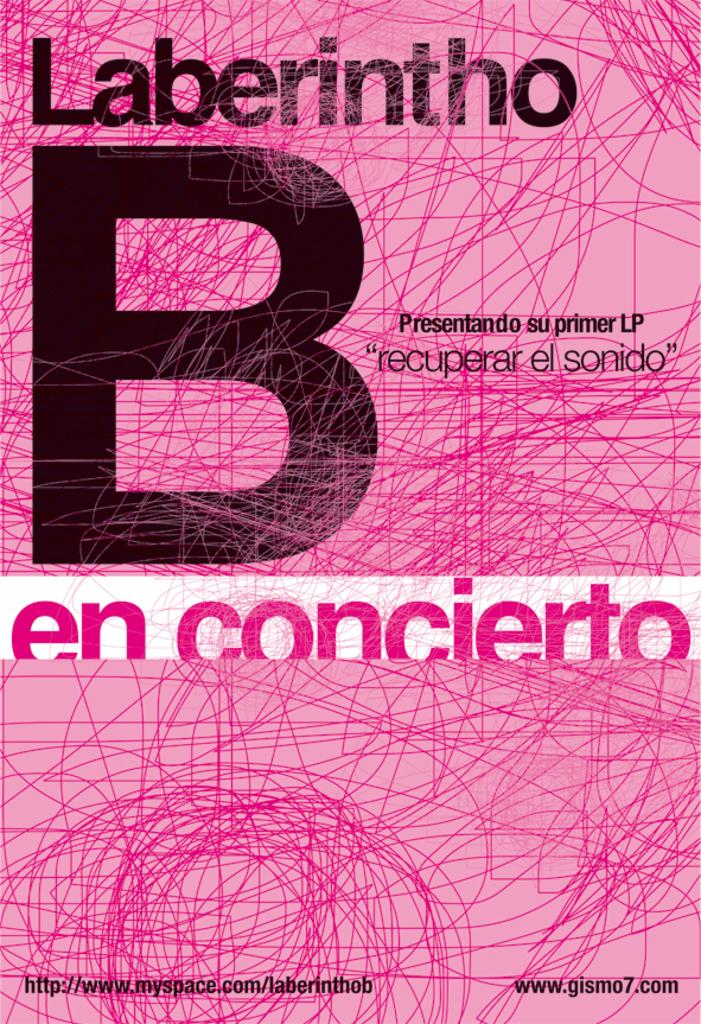<image>
Create a compact narrative representing the image presented. A book cover in Pepto Bismol pink with a huge B on it. 